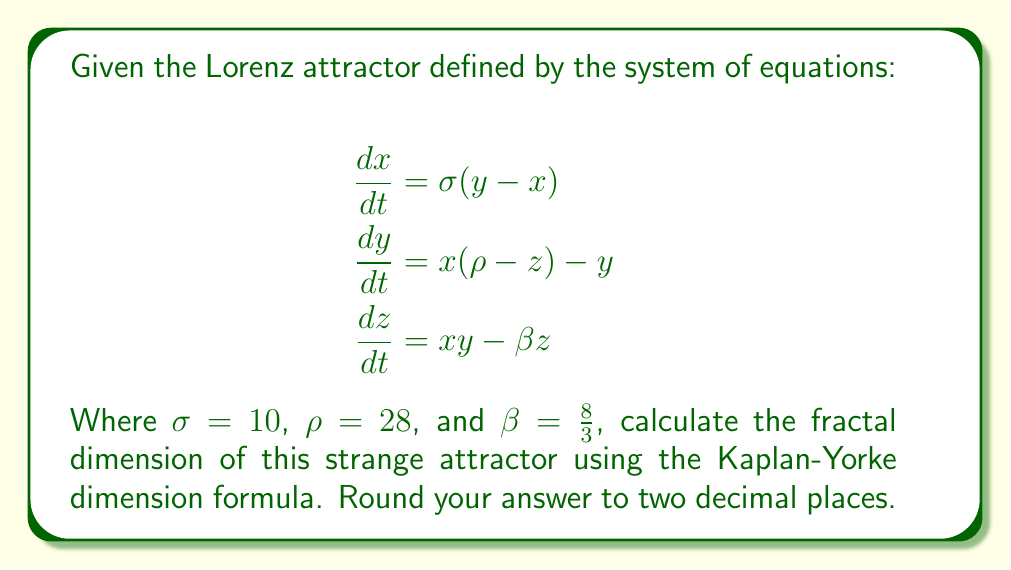Show me your answer to this math problem. To determine the fractal dimension of the Lorenz attractor, we'll use the Kaplan-Yorke dimension formula:

1) First, we need to calculate the Lyapunov exponents of the system. For the Lorenz attractor with the given parameters, the Lyapunov exponents are approximately:

   $\lambda_1 \approx 0.9056$
   $\lambda_2 \approx 0$
   $\lambda_3 \approx -14.5723$

2) The Kaplan-Yorke dimension is defined as:

   $$D_{KY} = j + \frac{\sum_{i=1}^j \lambda_i}{|\lambda_{j+1}|}$$

   Where $j$ is the largest integer such that $\sum_{i=1}^j \lambda_i \geq 0$

3) In this case, $j = 2$ because:
   $\lambda_1 + \lambda_2 = 0.9056 + 0 = 0.9056 > 0$
   But $\lambda_1 + \lambda_2 + \lambda_3 < 0$

4) Now we can apply the formula:

   $$D_{KY} = 2 + \frac{\lambda_1 + \lambda_2}{|\lambda_3|}$$

5) Substituting the values:

   $$D_{KY} = 2 + \frac{0.9056 + 0}{|14.5723|} = 2 + \frac{0.9056}{14.5723} \approx 2.0621$$

6) Rounding to two decimal places:

   $D_{KY} \approx 2.06$

This fractal dimension between 2 and 3 indicates that the Lorenz attractor is a fractal object with a dimension slightly higher than a 2D surface but less than a 3D volume, which aligns with its observed complex, non-integer dimensional nature.
Answer: 2.06 